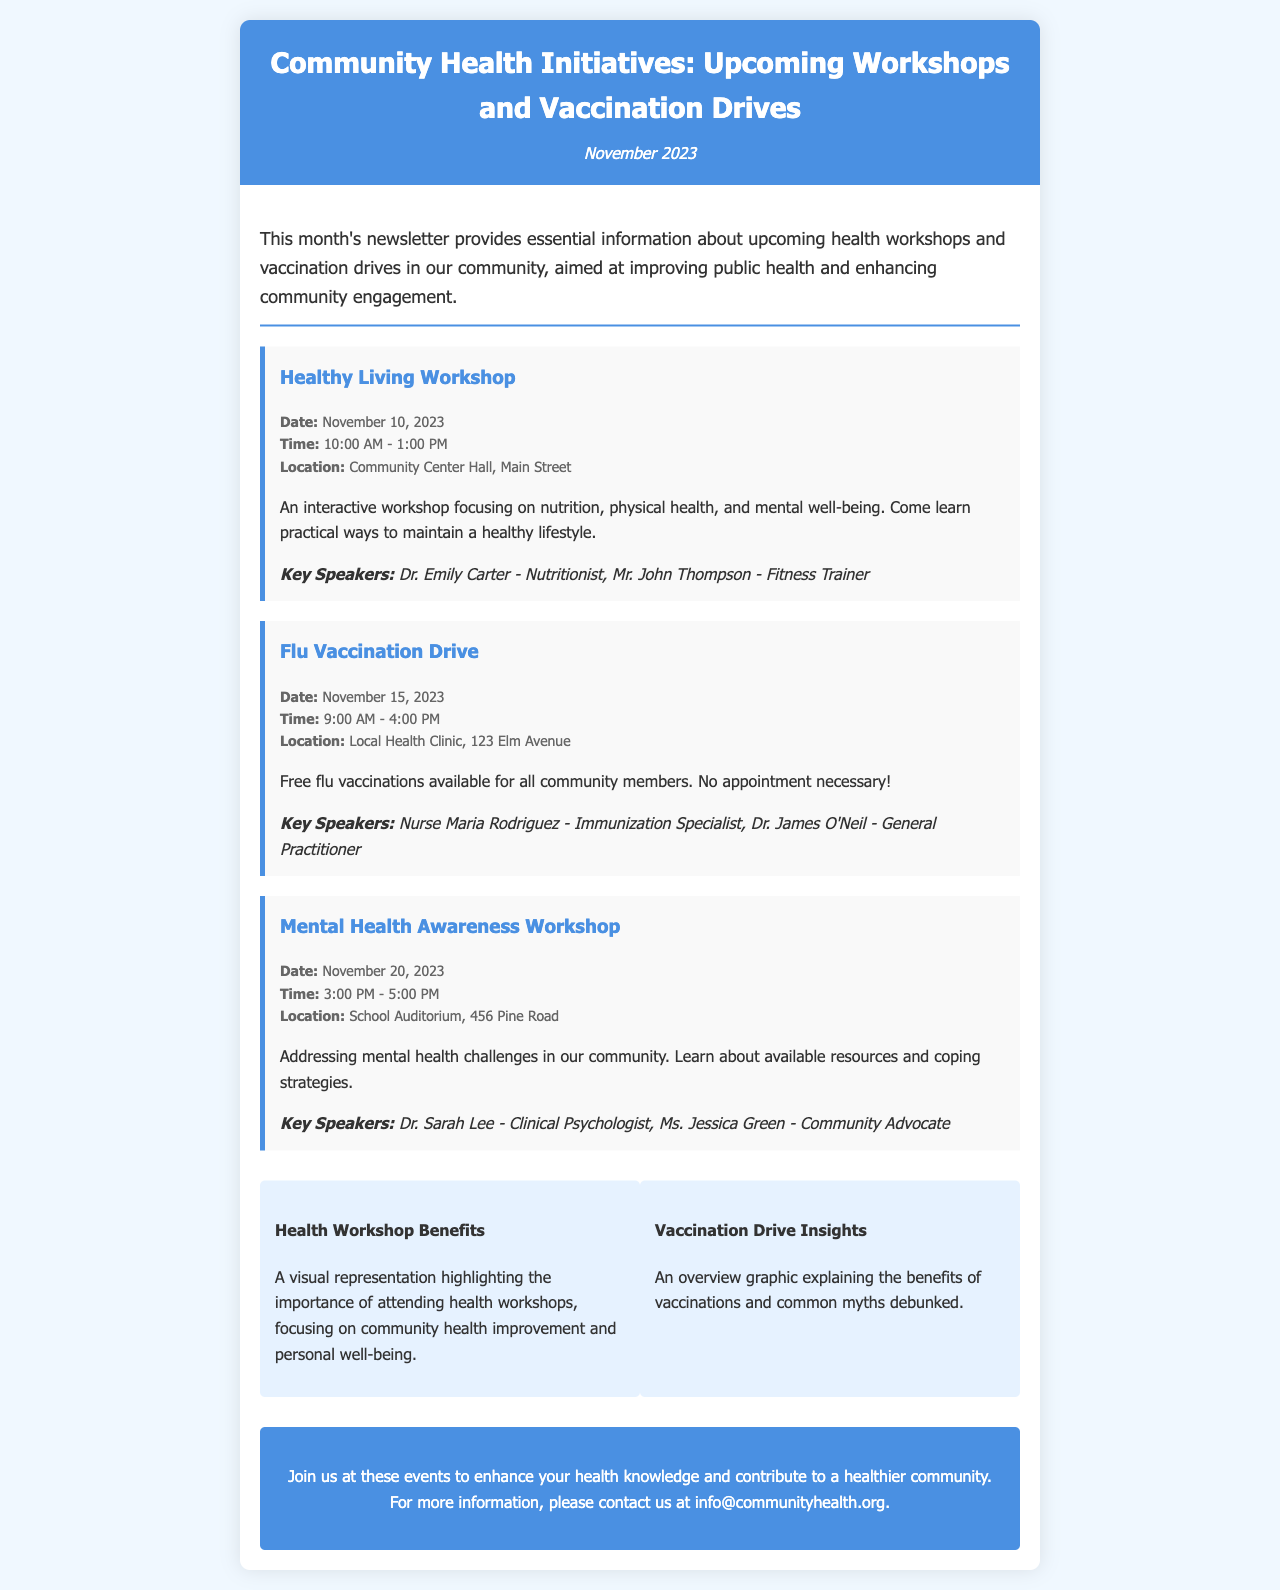What is the date of the Healthy Living Workshop? The date is specified in the event details for the Healthy Living Workshop.
Answer: November 10, 2023 What time does the Flu Vaccination Drive start? The starting time for the Flu Vaccination Drive is listed in the event details.
Answer: 9:00 AM Who is the Nutritionist speaking at the Healthy Living Workshop? The document lists the speakers for each event, including the Nutritionist for the Healthy Living Workshop.
Answer: Dr. Emily Carter How many events are taking place in November? The document mentions the number of different workshops and drives taking place in November.
Answer: Three What is the location of the Mental Health Awareness Workshop? The location is provided in the event details for the Mental Health Awareness Workshop.
Answer: School Auditorium, 456 Pine Road What type of health issues does the Mental Health Awareness Workshop address? The description of the workshop indicates the key topic being discussed.
Answer: Mental health challenges Who is the Immunization Specialist at the Flu Vaccination Drive? This information is given in the speakers section for the Flu Vaccination Drive.
Answer: Nurse Maria Rodriguez What is a key benefit of attending health workshops according to the visuals? The document mentions benefits of attending health workshops in the visuals section.
Answer: Community health improvement What is the email contact for more information? The contact information is provided at the end of the document for inquiries.
Answer: info@communityhealth.org 